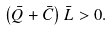Convert formula to latex. <formula><loc_0><loc_0><loc_500><loc_500>\left ( \bar { Q } + \bar { C } \right ) \bar { L } > 0 .</formula> 